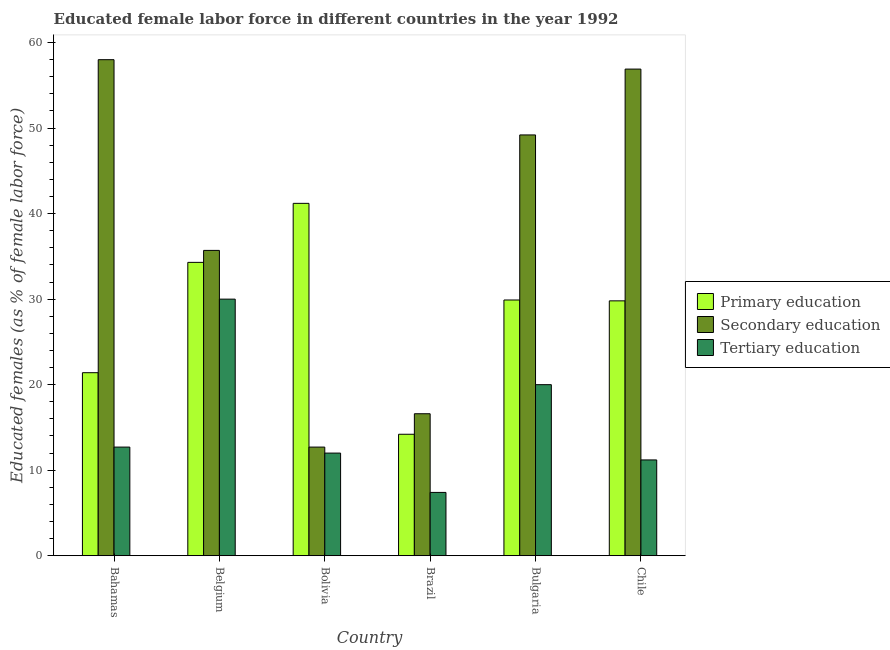How many groups of bars are there?
Ensure brevity in your answer.  6. Are the number of bars per tick equal to the number of legend labels?
Keep it short and to the point. Yes. How many bars are there on the 3rd tick from the right?
Provide a succinct answer. 3. What is the percentage of female labor force who received tertiary education in Chile?
Make the answer very short. 11.2. Across all countries, what is the maximum percentage of female labor force who received primary education?
Keep it short and to the point. 41.2. Across all countries, what is the minimum percentage of female labor force who received primary education?
Provide a short and direct response. 14.2. In which country was the percentage of female labor force who received tertiary education maximum?
Offer a terse response. Belgium. What is the total percentage of female labor force who received tertiary education in the graph?
Your answer should be compact. 93.3. What is the difference between the percentage of female labor force who received tertiary education in Bahamas and that in Chile?
Provide a short and direct response. 1.5. What is the difference between the percentage of female labor force who received secondary education in Bahamas and the percentage of female labor force who received tertiary education in Belgium?
Provide a short and direct response. 28. What is the average percentage of female labor force who received secondary education per country?
Make the answer very short. 38.18. What is the difference between the percentage of female labor force who received tertiary education and percentage of female labor force who received secondary education in Chile?
Offer a very short reply. -45.7. What is the ratio of the percentage of female labor force who received secondary education in Brazil to that in Bulgaria?
Your answer should be very brief. 0.34. Is the difference between the percentage of female labor force who received tertiary education in Belgium and Chile greater than the difference between the percentage of female labor force who received primary education in Belgium and Chile?
Keep it short and to the point. Yes. What is the difference between the highest and the second highest percentage of female labor force who received secondary education?
Offer a very short reply. 1.1. What is the difference between the highest and the lowest percentage of female labor force who received secondary education?
Provide a succinct answer. 45.3. What does the 3rd bar from the left in Brazil represents?
Provide a succinct answer. Tertiary education. What does the 2nd bar from the right in Chile represents?
Keep it short and to the point. Secondary education. Is it the case that in every country, the sum of the percentage of female labor force who received primary education and percentage of female labor force who received secondary education is greater than the percentage of female labor force who received tertiary education?
Offer a very short reply. Yes. Are all the bars in the graph horizontal?
Offer a terse response. No. How many countries are there in the graph?
Offer a terse response. 6. Are the values on the major ticks of Y-axis written in scientific E-notation?
Your response must be concise. No. Where does the legend appear in the graph?
Your answer should be compact. Center right. How are the legend labels stacked?
Ensure brevity in your answer.  Vertical. What is the title of the graph?
Ensure brevity in your answer.  Educated female labor force in different countries in the year 1992. What is the label or title of the Y-axis?
Your answer should be compact. Educated females (as % of female labor force). What is the Educated females (as % of female labor force) of Primary education in Bahamas?
Provide a short and direct response. 21.4. What is the Educated females (as % of female labor force) of Tertiary education in Bahamas?
Keep it short and to the point. 12.7. What is the Educated females (as % of female labor force) in Primary education in Belgium?
Your response must be concise. 34.3. What is the Educated females (as % of female labor force) in Secondary education in Belgium?
Provide a short and direct response. 35.7. What is the Educated females (as % of female labor force) in Primary education in Bolivia?
Give a very brief answer. 41.2. What is the Educated females (as % of female labor force) in Secondary education in Bolivia?
Your answer should be compact. 12.7. What is the Educated females (as % of female labor force) of Primary education in Brazil?
Your response must be concise. 14.2. What is the Educated females (as % of female labor force) in Secondary education in Brazil?
Your answer should be very brief. 16.6. What is the Educated females (as % of female labor force) of Tertiary education in Brazil?
Provide a short and direct response. 7.4. What is the Educated females (as % of female labor force) in Primary education in Bulgaria?
Ensure brevity in your answer.  29.9. What is the Educated females (as % of female labor force) in Secondary education in Bulgaria?
Give a very brief answer. 49.2. What is the Educated females (as % of female labor force) of Primary education in Chile?
Your answer should be very brief. 29.8. What is the Educated females (as % of female labor force) in Secondary education in Chile?
Ensure brevity in your answer.  56.9. What is the Educated females (as % of female labor force) in Tertiary education in Chile?
Your answer should be compact. 11.2. Across all countries, what is the maximum Educated females (as % of female labor force) of Primary education?
Provide a short and direct response. 41.2. Across all countries, what is the maximum Educated females (as % of female labor force) of Secondary education?
Give a very brief answer. 58. Across all countries, what is the minimum Educated females (as % of female labor force) in Primary education?
Your answer should be very brief. 14.2. Across all countries, what is the minimum Educated females (as % of female labor force) in Secondary education?
Give a very brief answer. 12.7. Across all countries, what is the minimum Educated females (as % of female labor force) in Tertiary education?
Provide a succinct answer. 7.4. What is the total Educated females (as % of female labor force) of Primary education in the graph?
Offer a very short reply. 170.8. What is the total Educated females (as % of female labor force) in Secondary education in the graph?
Provide a succinct answer. 229.1. What is the total Educated females (as % of female labor force) in Tertiary education in the graph?
Your answer should be very brief. 93.3. What is the difference between the Educated females (as % of female labor force) in Secondary education in Bahamas and that in Belgium?
Give a very brief answer. 22.3. What is the difference between the Educated females (as % of female labor force) in Tertiary education in Bahamas and that in Belgium?
Offer a terse response. -17.3. What is the difference between the Educated females (as % of female labor force) in Primary education in Bahamas and that in Bolivia?
Provide a succinct answer. -19.8. What is the difference between the Educated females (as % of female labor force) in Secondary education in Bahamas and that in Bolivia?
Provide a succinct answer. 45.3. What is the difference between the Educated females (as % of female labor force) in Tertiary education in Bahamas and that in Bolivia?
Your response must be concise. 0.7. What is the difference between the Educated females (as % of female labor force) of Primary education in Bahamas and that in Brazil?
Your response must be concise. 7.2. What is the difference between the Educated females (as % of female labor force) in Secondary education in Bahamas and that in Brazil?
Make the answer very short. 41.4. What is the difference between the Educated females (as % of female labor force) of Tertiary education in Bahamas and that in Brazil?
Offer a terse response. 5.3. What is the difference between the Educated females (as % of female labor force) of Primary education in Bahamas and that in Bulgaria?
Keep it short and to the point. -8.5. What is the difference between the Educated females (as % of female labor force) of Secondary education in Bahamas and that in Bulgaria?
Provide a short and direct response. 8.8. What is the difference between the Educated females (as % of female labor force) of Tertiary education in Bahamas and that in Chile?
Offer a terse response. 1.5. What is the difference between the Educated females (as % of female labor force) of Primary education in Belgium and that in Bolivia?
Provide a succinct answer. -6.9. What is the difference between the Educated females (as % of female labor force) of Primary education in Belgium and that in Brazil?
Your answer should be very brief. 20.1. What is the difference between the Educated females (as % of female labor force) in Tertiary education in Belgium and that in Brazil?
Ensure brevity in your answer.  22.6. What is the difference between the Educated females (as % of female labor force) of Primary education in Belgium and that in Bulgaria?
Your answer should be very brief. 4.4. What is the difference between the Educated females (as % of female labor force) of Secondary education in Belgium and that in Bulgaria?
Your answer should be very brief. -13.5. What is the difference between the Educated females (as % of female labor force) in Tertiary education in Belgium and that in Bulgaria?
Your response must be concise. 10. What is the difference between the Educated females (as % of female labor force) of Secondary education in Belgium and that in Chile?
Provide a short and direct response. -21.2. What is the difference between the Educated females (as % of female labor force) of Primary education in Bolivia and that in Brazil?
Provide a short and direct response. 27. What is the difference between the Educated females (as % of female labor force) in Secondary education in Bolivia and that in Brazil?
Offer a very short reply. -3.9. What is the difference between the Educated females (as % of female labor force) in Primary education in Bolivia and that in Bulgaria?
Your answer should be compact. 11.3. What is the difference between the Educated females (as % of female labor force) in Secondary education in Bolivia and that in Bulgaria?
Ensure brevity in your answer.  -36.5. What is the difference between the Educated females (as % of female labor force) in Tertiary education in Bolivia and that in Bulgaria?
Offer a terse response. -8. What is the difference between the Educated females (as % of female labor force) in Primary education in Bolivia and that in Chile?
Your answer should be compact. 11.4. What is the difference between the Educated females (as % of female labor force) of Secondary education in Bolivia and that in Chile?
Keep it short and to the point. -44.2. What is the difference between the Educated females (as % of female labor force) in Tertiary education in Bolivia and that in Chile?
Your answer should be compact. 0.8. What is the difference between the Educated females (as % of female labor force) of Primary education in Brazil and that in Bulgaria?
Your answer should be compact. -15.7. What is the difference between the Educated females (as % of female labor force) of Secondary education in Brazil and that in Bulgaria?
Your answer should be very brief. -32.6. What is the difference between the Educated females (as % of female labor force) of Primary education in Brazil and that in Chile?
Your response must be concise. -15.6. What is the difference between the Educated females (as % of female labor force) of Secondary education in Brazil and that in Chile?
Provide a succinct answer. -40.3. What is the difference between the Educated females (as % of female labor force) in Tertiary education in Brazil and that in Chile?
Your answer should be very brief. -3.8. What is the difference between the Educated females (as % of female labor force) in Secondary education in Bulgaria and that in Chile?
Provide a short and direct response. -7.7. What is the difference between the Educated females (as % of female labor force) of Primary education in Bahamas and the Educated females (as % of female labor force) of Secondary education in Belgium?
Provide a succinct answer. -14.3. What is the difference between the Educated females (as % of female labor force) of Secondary education in Bahamas and the Educated females (as % of female labor force) of Tertiary education in Belgium?
Provide a short and direct response. 28. What is the difference between the Educated females (as % of female labor force) of Primary education in Bahamas and the Educated females (as % of female labor force) of Tertiary education in Bolivia?
Make the answer very short. 9.4. What is the difference between the Educated females (as % of female labor force) of Secondary education in Bahamas and the Educated females (as % of female labor force) of Tertiary education in Bolivia?
Provide a succinct answer. 46. What is the difference between the Educated females (as % of female labor force) in Primary education in Bahamas and the Educated females (as % of female labor force) in Secondary education in Brazil?
Provide a short and direct response. 4.8. What is the difference between the Educated females (as % of female labor force) of Primary education in Bahamas and the Educated females (as % of female labor force) of Tertiary education in Brazil?
Give a very brief answer. 14. What is the difference between the Educated females (as % of female labor force) of Secondary education in Bahamas and the Educated females (as % of female labor force) of Tertiary education in Brazil?
Provide a succinct answer. 50.6. What is the difference between the Educated females (as % of female labor force) in Primary education in Bahamas and the Educated females (as % of female labor force) in Secondary education in Bulgaria?
Your response must be concise. -27.8. What is the difference between the Educated females (as % of female labor force) in Primary education in Bahamas and the Educated females (as % of female labor force) in Tertiary education in Bulgaria?
Make the answer very short. 1.4. What is the difference between the Educated females (as % of female labor force) in Secondary education in Bahamas and the Educated females (as % of female labor force) in Tertiary education in Bulgaria?
Your answer should be compact. 38. What is the difference between the Educated females (as % of female labor force) of Primary education in Bahamas and the Educated females (as % of female labor force) of Secondary education in Chile?
Your response must be concise. -35.5. What is the difference between the Educated females (as % of female labor force) in Primary education in Bahamas and the Educated females (as % of female labor force) in Tertiary education in Chile?
Your response must be concise. 10.2. What is the difference between the Educated females (as % of female labor force) of Secondary education in Bahamas and the Educated females (as % of female labor force) of Tertiary education in Chile?
Keep it short and to the point. 46.8. What is the difference between the Educated females (as % of female labor force) of Primary education in Belgium and the Educated females (as % of female labor force) of Secondary education in Bolivia?
Give a very brief answer. 21.6. What is the difference between the Educated females (as % of female labor force) of Primary education in Belgium and the Educated females (as % of female labor force) of Tertiary education in Bolivia?
Your answer should be very brief. 22.3. What is the difference between the Educated females (as % of female labor force) of Secondary education in Belgium and the Educated females (as % of female labor force) of Tertiary education in Bolivia?
Your response must be concise. 23.7. What is the difference between the Educated females (as % of female labor force) in Primary education in Belgium and the Educated females (as % of female labor force) in Tertiary education in Brazil?
Keep it short and to the point. 26.9. What is the difference between the Educated females (as % of female labor force) in Secondary education in Belgium and the Educated females (as % of female labor force) in Tertiary education in Brazil?
Offer a terse response. 28.3. What is the difference between the Educated females (as % of female labor force) of Primary education in Belgium and the Educated females (as % of female labor force) of Secondary education in Bulgaria?
Provide a short and direct response. -14.9. What is the difference between the Educated females (as % of female labor force) of Primary education in Belgium and the Educated females (as % of female labor force) of Tertiary education in Bulgaria?
Provide a succinct answer. 14.3. What is the difference between the Educated females (as % of female labor force) of Primary education in Belgium and the Educated females (as % of female labor force) of Secondary education in Chile?
Keep it short and to the point. -22.6. What is the difference between the Educated females (as % of female labor force) in Primary education in Belgium and the Educated females (as % of female labor force) in Tertiary education in Chile?
Your answer should be very brief. 23.1. What is the difference between the Educated females (as % of female labor force) in Primary education in Bolivia and the Educated females (as % of female labor force) in Secondary education in Brazil?
Give a very brief answer. 24.6. What is the difference between the Educated females (as % of female labor force) of Primary education in Bolivia and the Educated females (as % of female labor force) of Tertiary education in Brazil?
Your answer should be compact. 33.8. What is the difference between the Educated females (as % of female labor force) in Secondary education in Bolivia and the Educated females (as % of female labor force) in Tertiary education in Brazil?
Provide a succinct answer. 5.3. What is the difference between the Educated females (as % of female labor force) in Primary education in Bolivia and the Educated females (as % of female labor force) in Tertiary education in Bulgaria?
Offer a very short reply. 21.2. What is the difference between the Educated females (as % of female labor force) of Primary education in Bolivia and the Educated females (as % of female labor force) of Secondary education in Chile?
Make the answer very short. -15.7. What is the difference between the Educated females (as % of female labor force) in Primary education in Bolivia and the Educated females (as % of female labor force) in Tertiary education in Chile?
Give a very brief answer. 30. What is the difference between the Educated females (as % of female labor force) of Primary education in Brazil and the Educated females (as % of female labor force) of Secondary education in Bulgaria?
Give a very brief answer. -35. What is the difference between the Educated females (as % of female labor force) of Primary education in Brazil and the Educated females (as % of female labor force) of Secondary education in Chile?
Your response must be concise. -42.7. What is the difference between the Educated females (as % of female labor force) of Primary education in Bulgaria and the Educated females (as % of female labor force) of Secondary education in Chile?
Provide a succinct answer. -27. What is the difference between the Educated females (as % of female labor force) of Primary education in Bulgaria and the Educated females (as % of female labor force) of Tertiary education in Chile?
Offer a very short reply. 18.7. What is the difference between the Educated females (as % of female labor force) in Secondary education in Bulgaria and the Educated females (as % of female labor force) in Tertiary education in Chile?
Give a very brief answer. 38. What is the average Educated females (as % of female labor force) of Primary education per country?
Offer a terse response. 28.47. What is the average Educated females (as % of female labor force) of Secondary education per country?
Your answer should be very brief. 38.18. What is the average Educated females (as % of female labor force) of Tertiary education per country?
Your answer should be very brief. 15.55. What is the difference between the Educated females (as % of female labor force) in Primary education and Educated females (as % of female labor force) in Secondary education in Bahamas?
Keep it short and to the point. -36.6. What is the difference between the Educated females (as % of female labor force) of Secondary education and Educated females (as % of female labor force) of Tertiary education in Bahamas?
Your answer should be compact. 45.3. What is the difference between the Educated females (as % of female labor force) in Primary education and Educated females (as % of female labor force) in Secondary education in Belgium?
Offer a terse response. -1.4. What is the difference between the Educated females (as % of female labor force) in Primary education and Educated females (as % of female labor force) in Tertiary education in Belgium?
Offer a very short reply. 4.3. What is the difference between the Educated females (as % of female labor force) of Primary education and Educated females (as % of female labor force) of Tertiary education in Bolivia?
Provide a succinct answer. 29.2. What is the difference between the Educated females (as % of female labor force) of Secondary education and Educated females (as % of female labor force) of Tertiary education in Bolivia?
Your response must be concise. 0.7. What is the difference between the Educated females (as % of female labor force) in Primary education and Educated females (as % of female labor force) in Secondary education in Brazil?
Provide a short and direct response. -2.4. What is the difference between the Educated females (as % of female labor force) of Primary education and Educated females (as % of female labor force) of Tertiary education in Brazil?
Offer a very short reply. 6.8. What is the difference between the Educated females (as % of female labor force) in Secondary education and Educated females (as % of female labor force) in Tertiary education in Brazil?
Offer a terse response. 9.2. What is the difference between the Educated females (as % of female labor force) of Primary education and Educated females (as % of female labor force) of Secondary education in Bulgaria?
Keep it short and to the point. -19.3. What is the difference between the Educated females (as % of female labor force) of Primary education and Educated females (as % of female labor force) of Tertiary education in Bulgaria?
Your answer should be very brief. 9.9. What is the difference between the Educated females (as % of female labor force) of Secondary education and Educated females (as % of female labor force) of Tertiary education in Bulgaria?
Provide a succinct answer. 29.2. What is the difference between the Educated females (as % of female labor force) in Primary education and Educated females (as % of female labor force) in Secondary education in Chile?
Your response must be concise. -27.1. What is the difference between the Educated females (as % of female labor force) in Secondary education and Educated females (as % of female labor force) in Tertiary education in Chile?
Provide a short and direct response. 45.7. What is the ratio of the Educated females (as % of female labor force) in Primary education in Bahamas to that in Belgium?
Ensure brevity in your answer.  0.62. What is the ratio of the Educated females (as % of female labor force) of Secondary education in Bahamas to that in Belgium?
Make the answer very short. 1.62. What is the ratio of the Educated females (as % of female labor force) in Tertiary education in Bahamas to that in Belgium?
Your answer should be compact. 0.42. What is the ratio of the Educated females (as % of female labor force) of Primary education in Bahamas to that in Bolivia?
Offer a very short reply. 0.52. What is the ratio of the Educated females (as % of female labor force) in Secondary education in Bahamas to that in Bolivia?
Your answer should be compact. 4.57. What is the ratio of the Educated females (as % of female labor force) of Tertiary education in Bahamas to that in Bolivia?
Your response must be concise. 1.06. What is the ratio of the Educated females (as % of female labor force) in Primary education in Bahamas to that in Brazil?
Keep it short and to the point. 1.51. What is the ratio of the Educated females (as % of female labor force) of Secondary education in Bahamas to that in Brazil?
Provide a succinct answer. 3.49. What is the ratio of the Educated females (as % of female labor force) of Tertiary education in Bahamas to that in Brazil?
Provide a succinct answer. 1.72. What is the ratio of the Educated females (as % of female labor force) of Primary education in Bahamas to that in Bulgaria?
Offer a terse response. 0.72. What is the ratio of the Educated females (as % of female labor force) in Secondary education in Bahamas to that in Bulgaria?
Offer a terse response. 1.18. What is the ratio of the Educated females (as % of female labor force) in Tertiary education in Bahamas to that in Bulgaria?
Your response must be concise. 0.64. What is the ratio of the Educated females (as % of female labor force) in Primary education in Bahamas to that in Chile?
Your answer should be compact. 0.72. What is the ratio of the Educated females (as % of female labor force) in Secondary education in Bahamas to that in Chile?
Offer a terse response. 1.02. What is the ratio of the Educated females (as % of female labor force) in Tertiary education in Bahamas to that in Chile?
Your answer should be very brief. 1.13. What is the ratio of the Educated females (as % of female labor force) in Primary education in Belgium to that in Bolivia?
Ensure brevity in your answer.  0.83. What is the ratio of the Educated females (as % of female labor force) of Secondary education in Belgium to that in Bolivia?
Provide a succinct answer. 2.81. What is the ratio of the Educated females (as % of female labor force) of Tertiary education in Belgium to that in Bolivia?
Make the answer very short. 2.5. What is the ratio of the Educated females (as % of female labor force) in Primary education in Belgium to that in Brazil?
Ensure brevity in your answer.  2.42. What is the ratio of the Educated females (as % of female labor force) in Secondary education in Belgium to that in Brazil?
Ensure brevity in your answer.  2.15. What is the ratio of the Educated females (as % of female labor force) of Tertiary education in Belgium to that in Brazil?
Provide a short and direct response. 4.05. What is the ratio of the Educated females (as % of female labor force) in Primary education in Belgium to that in Bulgaria?
Offer a very short reply. 1.15. What is the ratio of the Educated females (as % of female labor force) of Secondary education in Belgium to that in Bulgaria?
Ensure brevity in your answer.  0.73. What is the ratio of the Educated females (as % of female labor force) of Tertiary education in Belgium to that in Bulgaria?
Ensure brevity in your answer.  1.5. What is the ratio of the Educated females (as % of female labor force) of Primary education in Belgium to that in Chile?
Your response must be concise. 1.15. What is the ratio of the Educated females (as % of female labor force) of Secondary education in Belgium to that in Chile?
Make the answer very short. 0.63. What is the ratio of the Educated females (as % of female labor force) in Tertiary education in Belgium to that in Chile?
Offer a terse response. 2.68. What is the ratio of the Educated females (as % of female labor force) of Primary education in Bolivia to that in Brazil?
Your answer should be very brief. 2.9. What is the ratio of the Educated females (as % of female labor force) in Secondary education in Bolivia to that in Brazil?
Provide a short and direct response. 0.77. What is the ratio of the Educated females (as % of female labor force) in Tertiary education in Bolivia to that in Brazil?
Your response must be concise. 1.62. What is the ratio of the Educated females (as % of female labor force) of Primary education in Bolivia to that in Bulgaria?
Give a very brief answer. 1.38. What is the ratio of the Educated females (as % of female labor force) of Secondary education in Bolivia to that in Bulgaria?
Provide a succinct answer. 0.26. What is the ratio of the Educated females (as % of female labor force) of Primary education in Bolivia to that in Chile?
Your response must be concise. 1.38. What is the ratio of the Educated females (as % of female labor force) in Secondary education in Bolivia to that in Chile?
Ensure brevity in your answer.  0.22. What is the ratio of the Educated females (as % of female labor force) of Tertiary education in Bolivia to that in Chile?
Your response must be concise. 1.07. What is the ratio of the Educated females (as % of female labor force) in Primary education in Brazil to that in Bulgaria?
Offer a very short reply. 0.47. What is the ratio of the Educated females (as % of female labor force) of Secondary education in Brazil to that in Bulgaria?
Your answer should be very brief. 0.34. What is the ratio of the Educated females (as % of female labor force) in Tertiary education in Brazil to that in Bulgaria?
Ensure brevity in your answer.  0.37. What is the ratio of the Educated females (as % of female labor force) in Primary education in Brazil to that in Chile?
Provide a succinct answer. 0.48. What is the ratio of the Educated females (as % of female labor force) in Secondary education in Brazil to that in Chile?
Offer a terse response. 0.29. What is the ratio of the Educated females (as % of female labor force) of Tertiary education in Brazil to that in Chile?
Offer a very short reply. 0.66. What is the ratio of the Educated females (as % of female labor force) in Secondary education in Bulgaria to that in Chile?
Provide a short and direct response. 0.86. What is the ratio of the Educated females (as % of female labor force) of Tertiary education in Bulgaria to that in Chile?
Your answer should be compact. 1.79. What is the difference between the highest and the second highest Educated females (as % of female labor force) in Primary education?
Your answer should be compact. 6.9. What is the difference between the highest and the second highest Educated females (as % of female labor force) in Secondary education?
Make the answer very short. 1.1. What is the difference between the highest and the lowest Educated females (as % of female labor force) of Secondary education?
Ensure brevity in your answer.  45.3. What is the difference between the highest and the lowest Educated females (as % of female labor force) of Tertiary education?
Your answer should be compact. 22.6. 